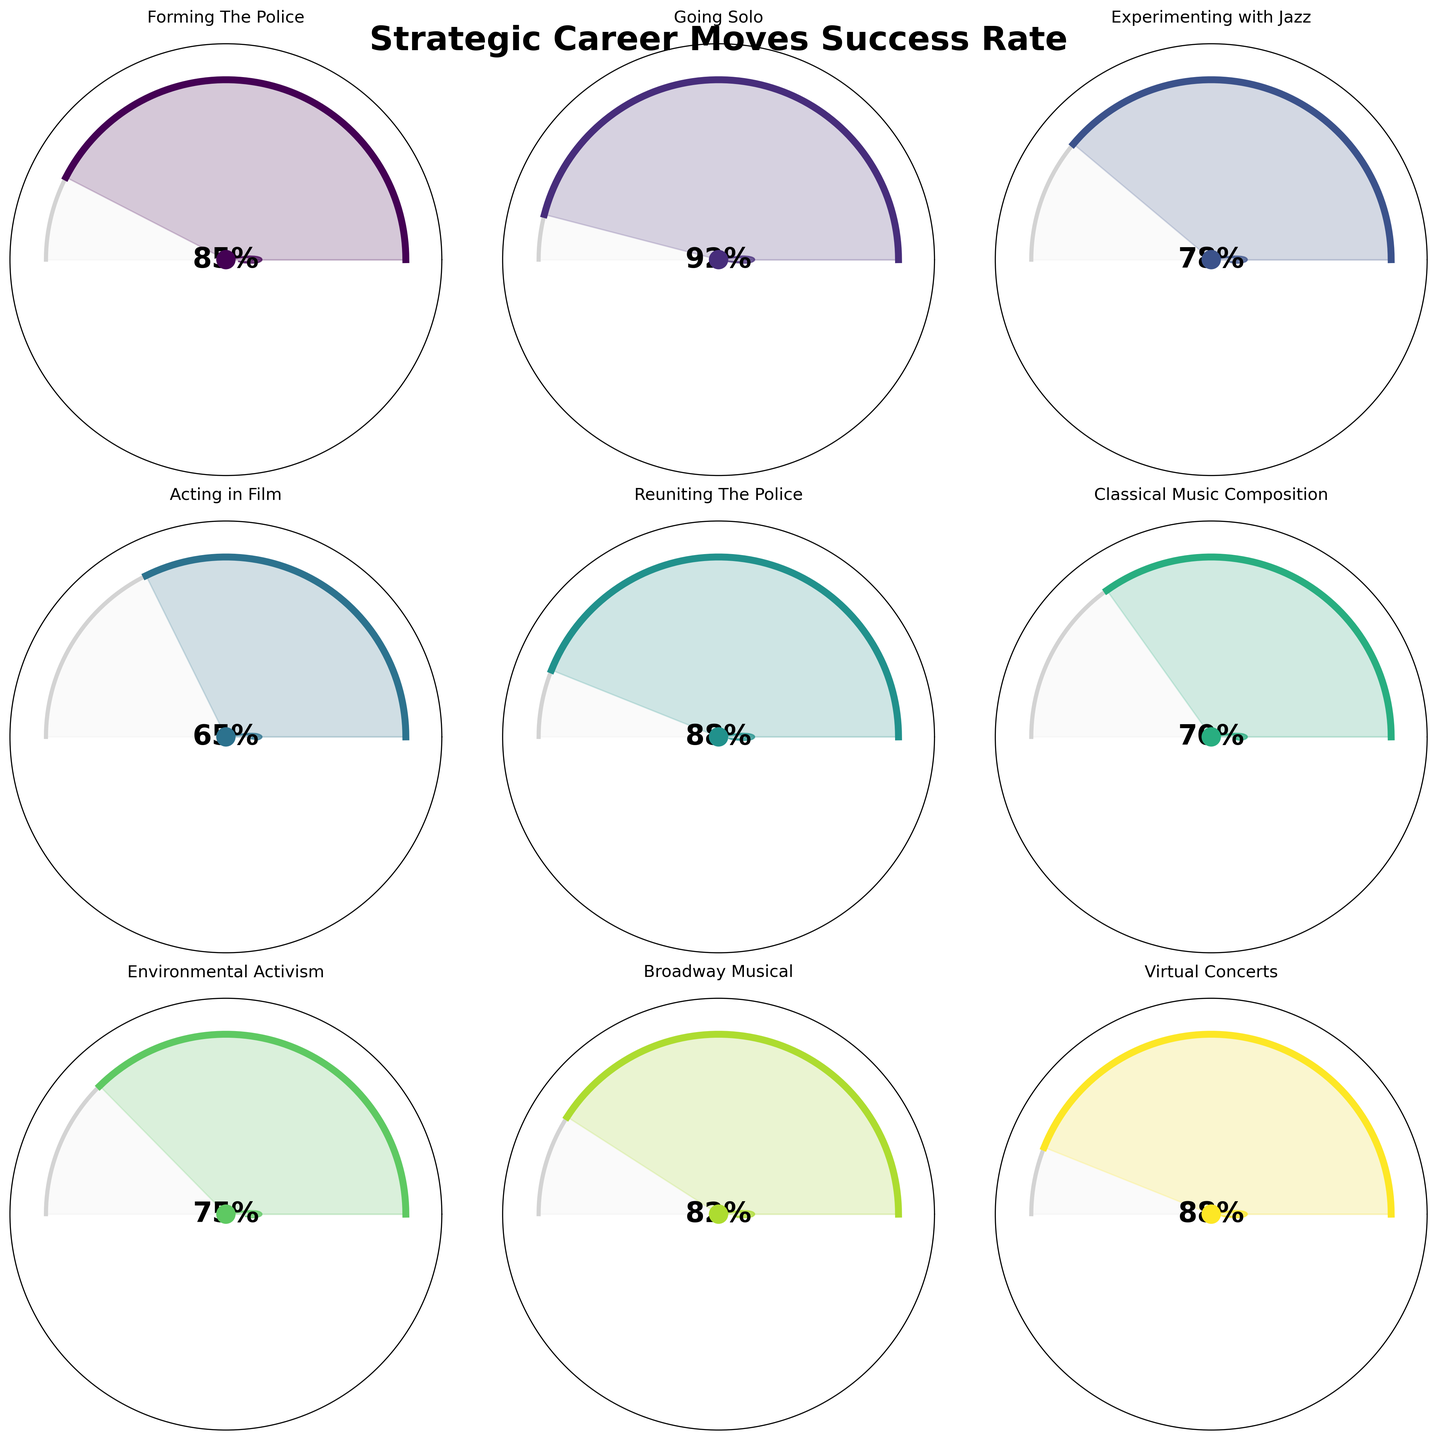What is the title of the figure? The title is the largest text placed at the top of the figure. By observing the topmost area, we can see the title.
Answer: Strategic Career Moves Success Rate How many career moves have been visualized in the figure? You can count the number of gauge charts present in the figure, which corresponds to the number of career moves.
Answer: 9 Which strategic career move has the highest success rate? By identifying the gauge chart with the highest percentage label at the center, we can determine the career move with the highest success rate.
Answer: Going Solo Which career move happened in 1995? Look for the gauge chart that has the year '1995' displayed at the bottom. The associated move name at the top of this gauge chart is the answer.
Answer: Acting in Film What is the success rate of the career move "Classical Music Composition" and in which year did it occur? First, locate the gauge chart labeled "Classical Music Composition" at the top. The success rate is the percentage at the center, and the year is the number at the bottom.
Answer: 70%, 2005 Which career move has a lower success rate: "Experimenting with Jazz" or "Environmental Activism"? Look for both the gauge charts labeled "Experimenting with Jazz" and "Environmental Activism". Compare the two percentages in the center of these charts to determine which one is lower.
Answer: Experimenting with Jazz What is the average success rate of the career moves in the 2000s (2000, 2005, 2010)? Add the success rates of the career moves in the years 2000, 2005, and 2010, then divide the total by 3. (88 + 70 + 75) / 3 = 77.67
Answer: 77.67% Which career move saw a success rate increase between 2015 and 2020? Compare the percentages of gauged charts for the years 2015 and 2020. Identify if there was an increase or decrease by directly reading the two values.
Answer: Virtual Concerts What is the success rate gap between the career moves "Reuniting The Police" and "Forming The Police"? Subtract the success rate of "Forming The Police" from "Reuniting The Police". 88 - 85 = 3
Answer: 3 Which decade shows the most consistent level of success rates, and what are those rates? Observe the success rates of the career moves in each decade. The most consistent decade would have the smallest variance among its years. Compare visually the 1980s (85, 92), 1990s (78, 65), 2000s (88, 70, 75), and 2010s (82, 88). The 1980s show the most consistent rates.
Answer: 1980s, 85 and 92 